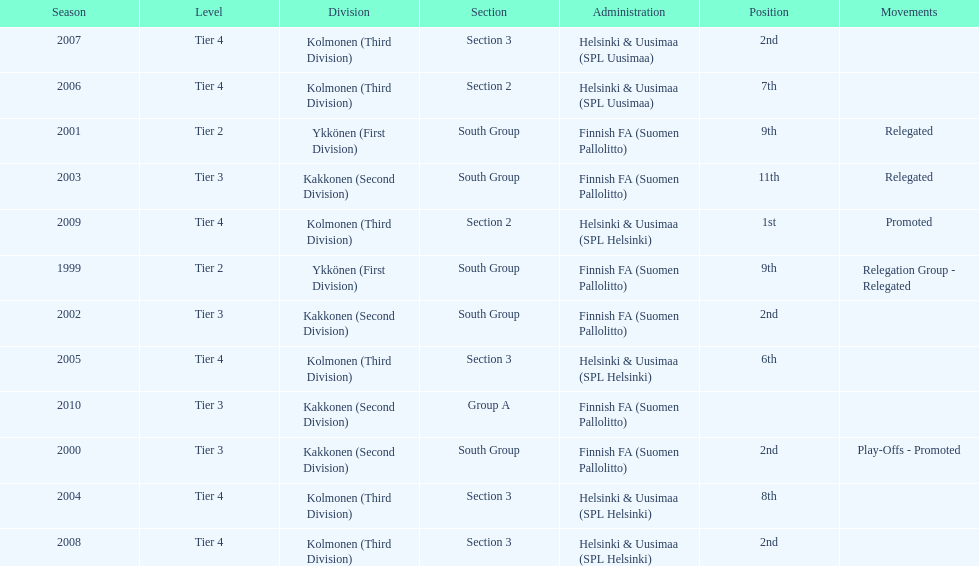How many consecutive times did they play in tier 4? 6. 